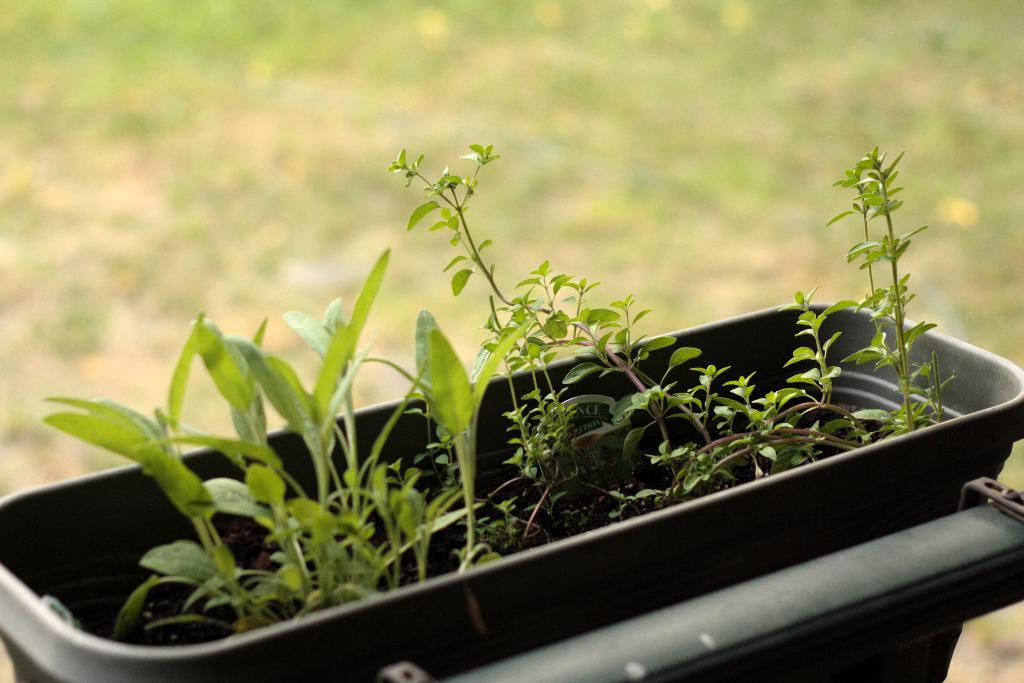What is inside the basket that is visible in the image? There is a basket with plants in the image. How is the basket positioned in the image? The basket is attached to an object. What can be observed about the background of the image? The background of the image is blurred. How does the coach help the plants grow in the image? There is no coach present in the image, and therefore no assistance can be provided to the plants. 